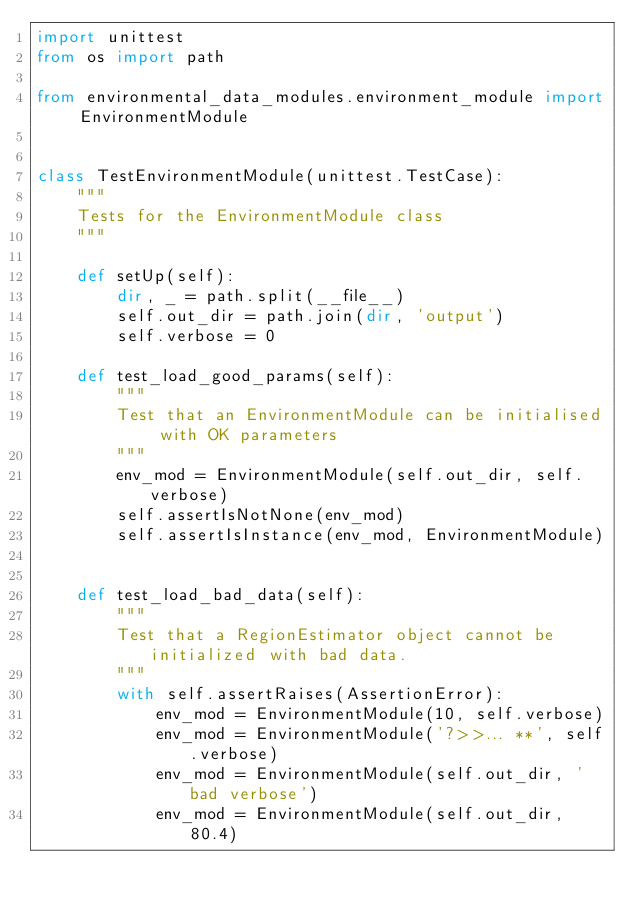<code> <loc_0><loc_0><loc_500><loc_500><_Python_>import unittest
from os import path

from environmental_data_modules.environment_module import EnvironmentModule


class TestEnvironmentModule(unittest.TestCase):
    """
    Tests for the EnvironmentModule class
    """

    def setUp(self):
        dir, _ = path.split(__file__)
        self.out_dir = path.join(dir, 'output')
        self.verbose = 0

    def test_load_good_params(self):
        """
        Test that an EnvironmentModule can be initialised with OK parameters
        """
        env_mod = EnvironmentModule(self.out_dir, self.verbose)
        self.assertIsNotNone(env_mod)
        self.assertIsInstance(env_mod, EnvironmentModule)


    def test_load_bad_data(self):
        """
        Test that a RegionEstimator object cannot be initialized with bad data.
        """
        with self.assertRaises(AssertionError):
            env_mod = EnvironmentModule(10, self.verbose)
            env_mod = EnvironmentModule('?>>... **', self.verbose)
            env_mod = EnvironmentModule(self.out_dir, 'bad verbose')
            env_mod = EnvironmentModule(self.out_dir, 80.4)

</code> 